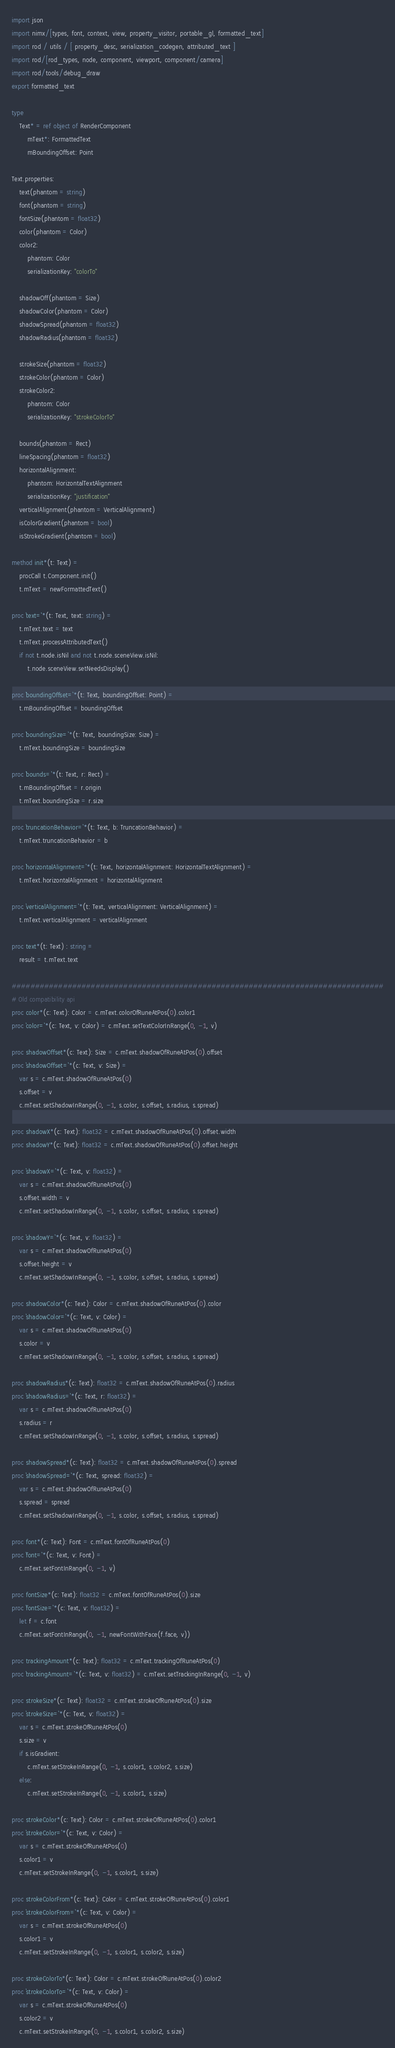Convert code to text. <code><loc_0><loc_0><loc_500><loc_500><_Nim_>import json
import nimx/[types, font, context, view, property_visitor, portable_gl, formatted_text]
import rod / utils / [ property_desc, serialization_codegen, attributed_text ]
import rod/[rod_types, node, component, viewport, component/camera]
import rod/tools/debug_draw
export formatted_text

type
    Text* = ref object of RenderComponent
        mText*: FormattedText
        mBoundingOffset: Point

Text.properties:
    text(phantom = string)
    font(phantom = string)
    fontSize(phantom = float32)
    color(phantom = Color)
    color2:
        phantom: Color
        serializationKey: "colorTo"

    shadowOff(phantom = Size)
    shadowColor(phantom = Color)
    shadowSpread(phantom = float32)
    shadowRadius(phantom = float32)

    strokeSize(phantom = float32)
    strokeColor(phantom = Color)
    strokeColor2:
        phantom: Color
        serializationKey: "strokeColorTo"

    bounds(phantom = Rect)
    lineSpacing(phantom = float32)
    horizontalAlignment:
        phantom: HorizontalTextAlignment
        serializationKey: "justification"
    verticalAlignment(phantom = VerticalAlignment)
    isColorGradient(phantom = bool)
    isStrokeGradient(phantom = bool)

method init*(t: Text) =
    procCall t.Component.init()
    t.mText = newFormattedText()

proc `text=`*(t: Text, text: string) =
    t.mText.text = text
    t.mText.processAttributedText()
    if not t.node.isNil and not t.node.sceneView.isNil:
        t.node.sceneView.setNeedsDisplay()

proc `boundingOffset=`*(t: Text, boundingOffset: Point) =
    t.mBoundingOffset = boundingOffset

proc `boundingSize=`*(t: Text, boundingSize: Size) =
    t.mText.boundingSize = boundingSize

proc `bounds=`*(t: Text, r: Rect) =
    t.mBoundingOffset = r.origin
    t.mText.boundingSize = r.size

proc `truncationBehavior=`*(t: Text, b: TruncationBehavior) =
    t.mText.truncationBehavior = b

proc `horizontalAlignment=`*(t: Text, horizontalAlignment: HorizontalTextAlignment) =
    t.mText.horizontalAlignment = horizontalAlignment

proc `verticalAlignment=`*(t: Text, verticalAlignment: VerticalAlignment) =
    t.mText.verticalAlignment = verticalAlignment

proc text*(t: Text) : string =
    result = t.mText.text

################################################################################
# Old compatibility api
proc color*(c: Text): Color = c.mText.colorOfRuneAtPos(0).color1
proc `color=`*(c: Text, v: Color) = c.mText.setTextColorInRange(0, -1, v)

proc shadowOffset*(c: Text): Size = c.mText.shadowOfRuneAtPos(0).offset
proc `shadowOffset=`*(c: Text, v: Size) =
    var s = c.mText.shadowOfRuneAtPos(0)
    s.offset = v
    c.mText.setShadowInRange(0, -1, s.color, s.offset, s.radius, s.spread)

proc shadowX*(c: Text): float32 = c.mText.shadowOfRuneAtPos(0).offset.width
proc shadowY*(c: Text): float32 = c.mText.shadowOfRuneAtPos(0).offset.height

proc `shadowX=`*(c: Text, v: float32) =
    var s = c.mText.shadowOfRuneAtPos(0)
    s.offset.width = v
    c.mText.setShadowInRange(0, -1, s.color, s.offset, s.radius, s.spread)

proc `shadowY=`*(c: Text, v: float32) =
    var s = c.mText.shadowOfRuneAtPos(0)
    s.offset.height = v
    c.mText.setShadowInRange(0, -1, s.color, s.offset, s.radius, s.spread)

proc shadowColor*(c: Text): Color = c.mText.shadowOfRuneAtPos(0).color
proc `shadowColor=`*(c: Text, v: Color) =
    var s = c.mText.shadowOfRuneAtPos(0)
    s.color = v
    c.mText.setShadowInRange(0, -1, s.color, s.offset, s.radius, s.spread)

proc shadowRadius*(c: Text): float32 = c.mText.shadowOfRuneAtPos(0).radius
proc `shadowRadius=`*(c: Text, r: float32) =
    var s = c.mText.shadowOfRuneAtPos(0)
    s.radius = r
    c.mText.setShadowInRange(0, -1, s.color, s.offset, s.radius, s.spread)

proc shadowSpread*(c: Text): float32 = c.mText.shadowOfRuneAtPos(0).spread
proc `shadowSpread=`*(c: Text, spread: float32) =
    var s = c.mText.shadowOfRuneAtPos(0)
    s.spread = spread
    c.mText.setShadowInRange(0, -1, s.color, s.offset, s.radius, s.spread)

proc font*(c: Text): Font = c.mText.fontOfRuneAtPos(0)
proc `font=`*(c: Text, v: Font) =
    c.mText.setFontInRange(0, -1, v)

proc fontSize*(c: Text): float32 = c.mText.fontOfRuneAtPos(0).size
proc `fontSize=`*(c: Text, v: float32) =
    let f = c.font
    c.mText.setFontInRange(0, -1, newFontWithFace(f.face, v))

proc trackingAmount*(c: Text): float32 = c.mText.trackingOfRuneAtPos(0)
proc `trackingAmount=`*(c: Text, v: float32) = c.mText.setTrackingInRange(0, -1, v)

proc strokeSize*(c: Text): float32 = c.mText.strokeOfRuneAtPos(0).size
proc `strokeSize=`*(c: Text, v: float32) =
    var s = c.mText.strokeOfRuneAtPos(0)
    s.size = v
    if s.isGradient:
        c.mText.setStrokeInRange(0, -1, s.color1, s.color2, s.size)
    else:
        c.mText.setStrokeInRange(0, -1, s.color1, s.size)

proc strokeColor*(c: Text): Color = c.mText.strokeOfRuneAtPos(0).color1
proc `strokeColor=`*(c: Text, v: Color) =
    var s = c.mText.strokeOfRuneAtPos(0)
    s.color1 = v
    c.mText.setStrokeInRange(0, -1, s.color1, s.size)

proc strokeColorFrom*(c: Text): Color = c.mText.strokeOfRuneAtPos(0).color1
proc `strokeColorFrom=`*(c: Text, v: Color) =
    var s = c.mText.strokeOfRuneAtPos(0)
    s.color1 = v
    c.mText.setStrokeInRange(0, -1, s.color1, s.color2, s.size)

proc strokeColorTo*(c: Text): Color = c.mText.strokeOfRuneAtPos(0).color2
proc `strokeColorTo=`*(c: Text, v: Color) =
    var s = c.mText.strokeOfRuneAtPos(0)
    s.color2 = v
    c.mText.setStrokeInRange(0, -1, s.color1, s.color2, s.size)
</code> 